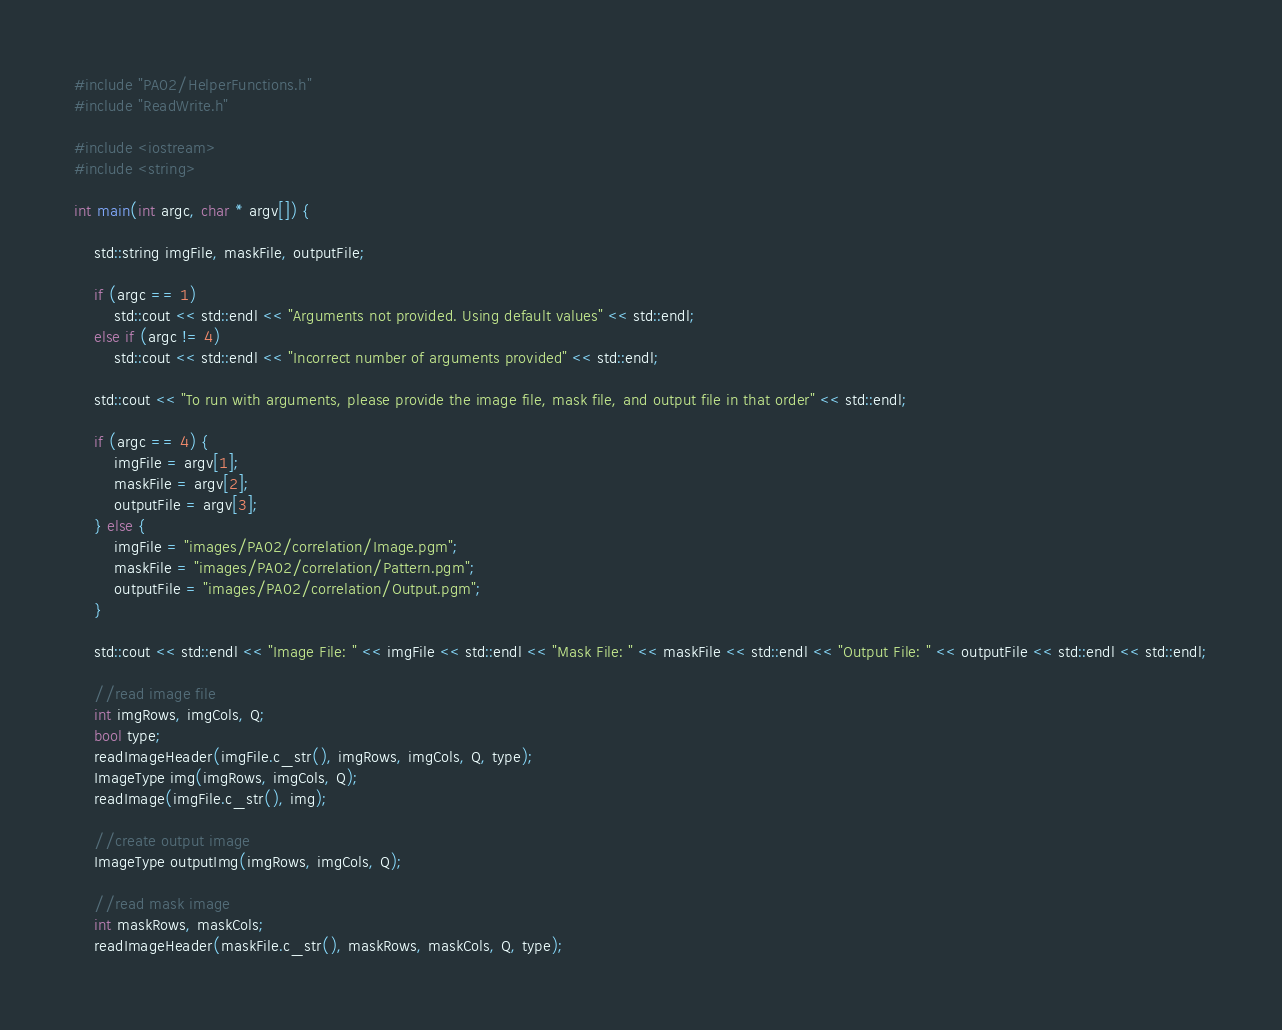Convert code to text. <code><loc_0><loc_0><loc_500><loc_500><_C++_>#include "PA02/HelperFunctions.h"
#include "ReadWrite.h"

#include <iostream>
#include <string>

int main(int argc, char * argv[]) {

    std::string imgFile, maskFile, outputFile;

    if (argc == 1)
        std::cout << std::endl << "Arguments not provided. Using default values" << std::endl;
    else if (argc != 4)
        std::cout << std::endl << "Incorrect number of arguments provided" << std::endl;

    std::cout << "To run with arguments, please provide the image file, mask file, and output file in that order" << std::endl;

    if (argc == 4) {
        imgFile = argv[1];
        maskFile = argv[2];
        outputFile = argv[3];
    } else {
        imgFile = "images/PA02/correlation/Image.pgm";
        maskFile = "images/PA02/correlation/Pattern.pgm";
        outputFile = "images/PA02/correlation/Output.pgm";
    }

    std::cout << std::endl << "Image File: " << imgFile << std::endl << "Mask File: " << maskFile << std::endl << "Output File: " << outputFile << std::endl << std::endl;

    //read image file
    int imgRows, imgCols, Q;
    bool type;
    readImageHeader(imgFile.c_str(), imgRows, imgCols, Q, type);
    ImageType img(imgRows, imgCols, Q);
    readImage(imgFile.c_str(), img);

    //create output image
    ImageType outputImg(imgRows, imgCols, Q);

    //read mask image
    int maskRows, maskCols;
    readImageHeader(maskFile.c_str(), maskRows, maskCols, Q, type);</code> 